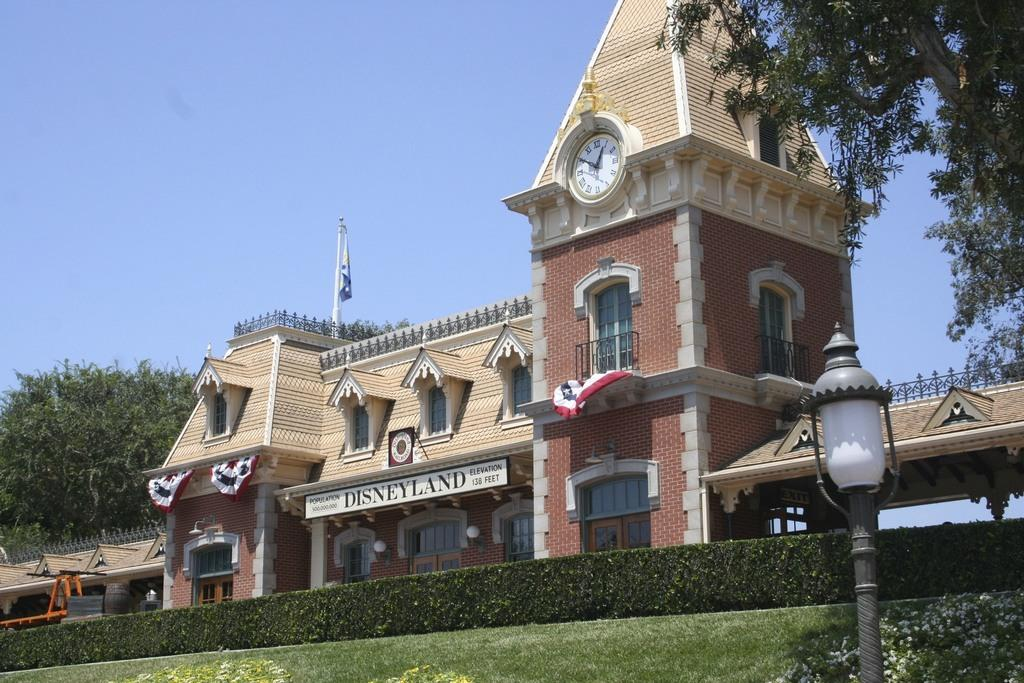Provide a one-sentence caption for the provided image. A building that looks old fashioned with the word disneyland across the front. 